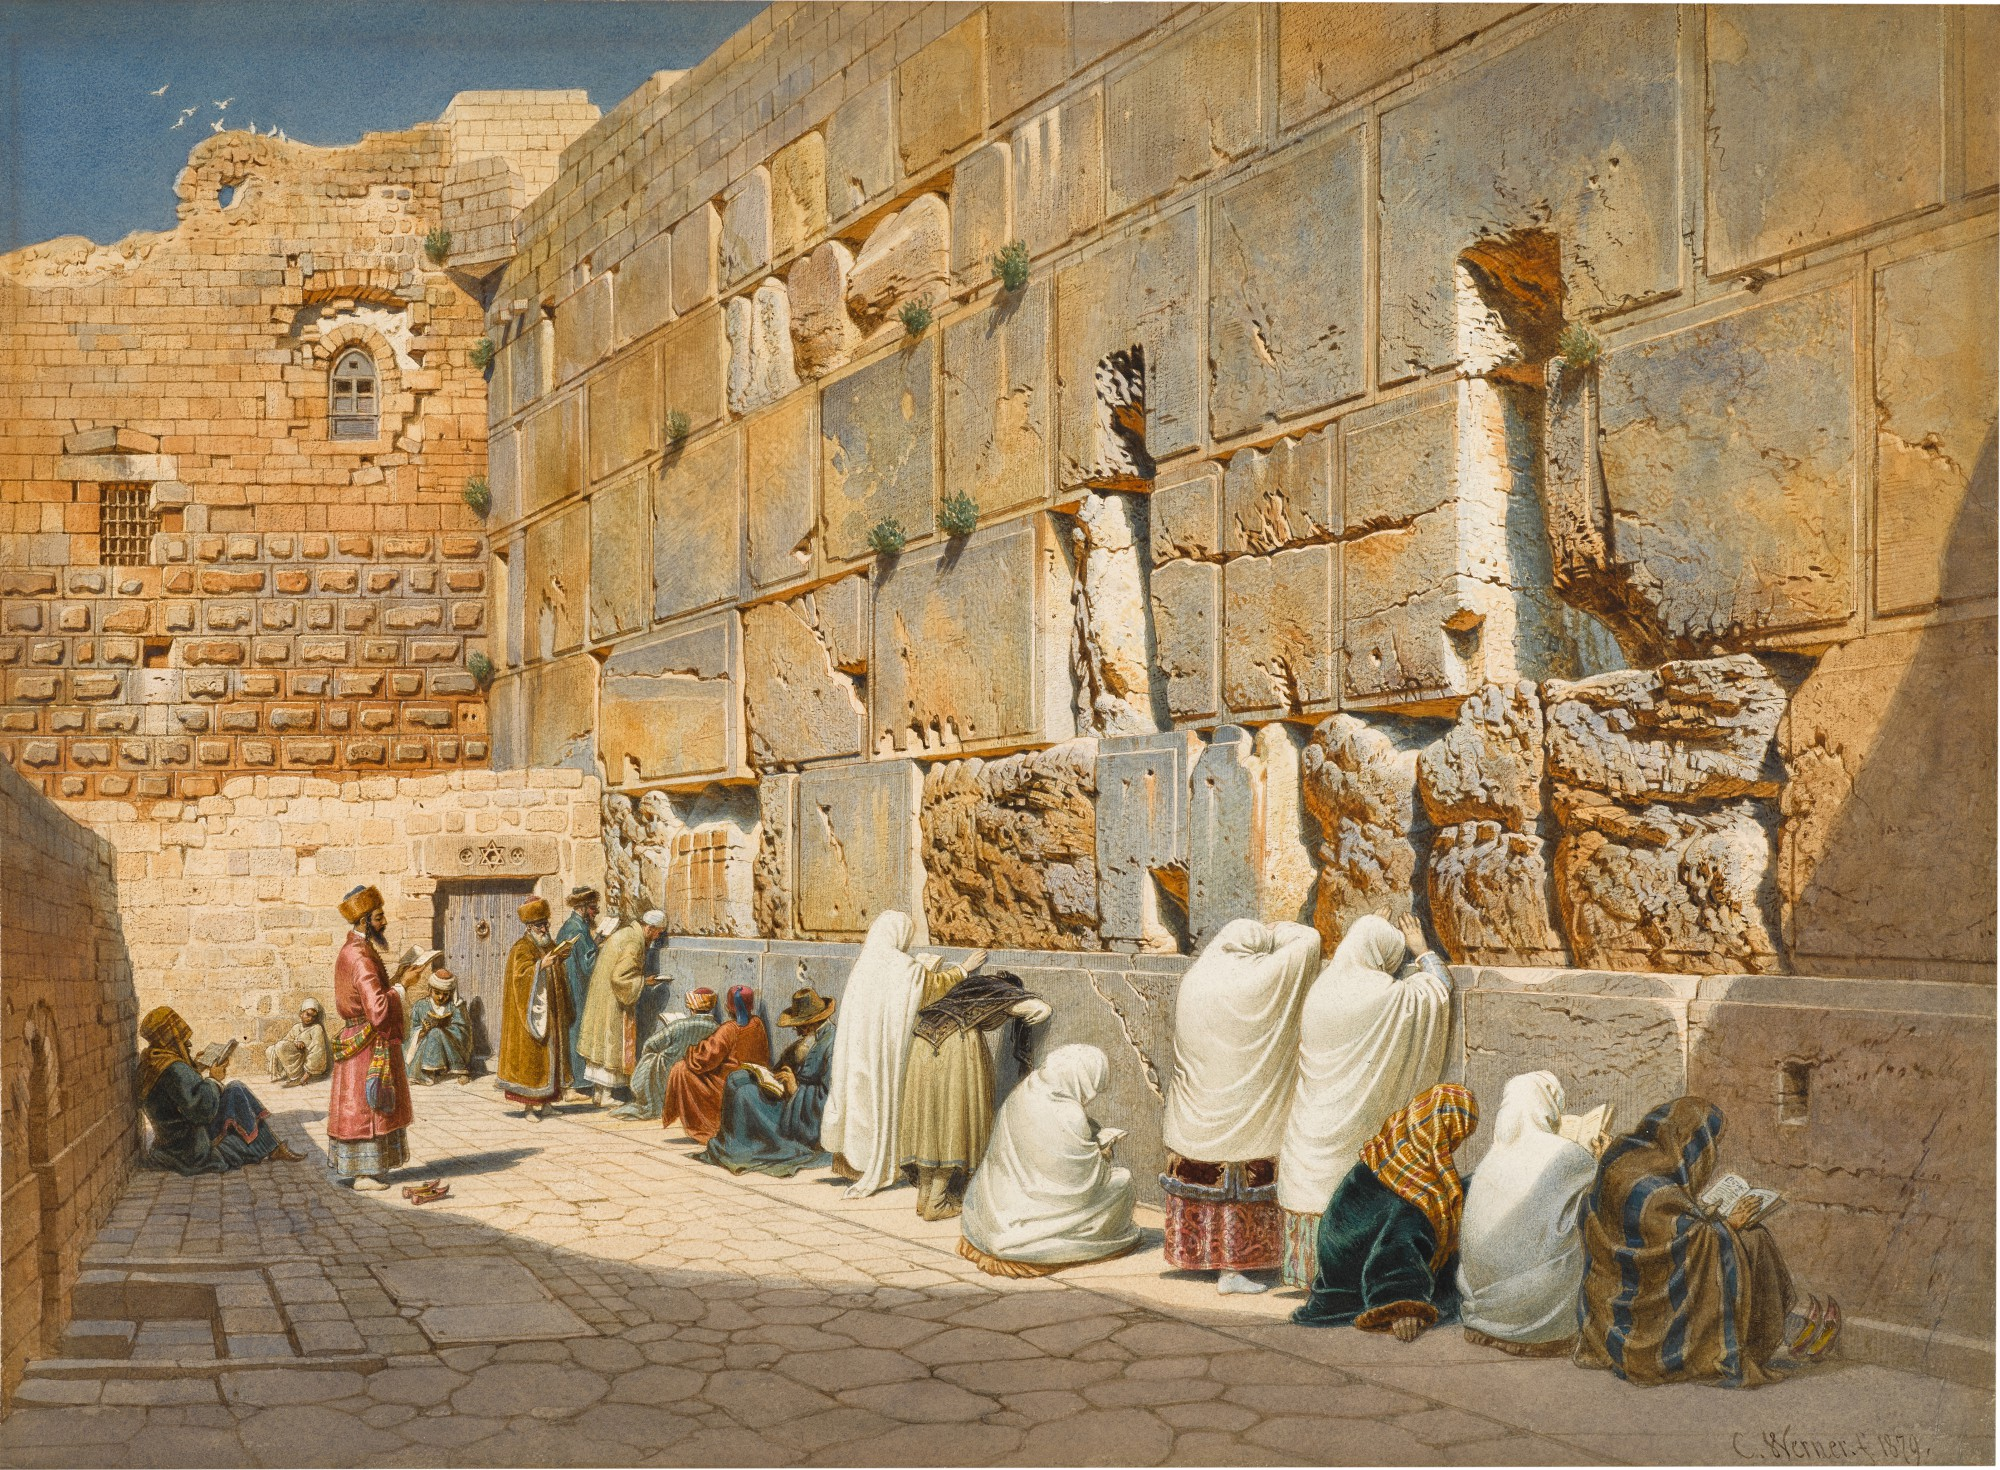Can you describe the attire of the individuals in this image? Certainly! The individuals in the image are dressed in a variety of attire that reflects traditional and religious clothing. Some wear long, flowing robes in whites and creams, signaling a form of devout or ceremonial dress. Others are in colorful garments, including blues and browns, which might be everyday clothes of the period the painting depicts. Attention to the head coverings reveals turbans and veils, suggesting the diverse cultural backgrounds and religious practices of the visitors to the Wall. 